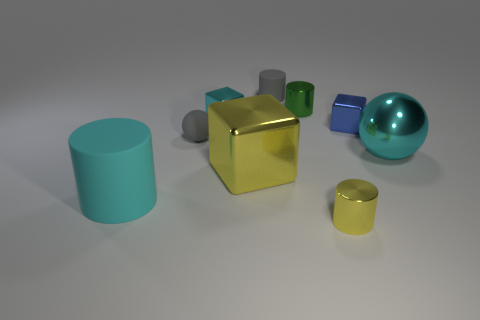Add 1 tiny brown objects. How many objects exist? 10 Subtract all blocks. How many objects are left? 6 Add 1 blue objects. How many blue objects are left? 2 Add 9 gray metal cylinders. How many gray metal cylinders exist? 9 Subtract 1 green cylinders. How many objects are left? 8 Subtract all tiny blue cubes. Subtract all big rubber cylinders. How many objects are left? 7 